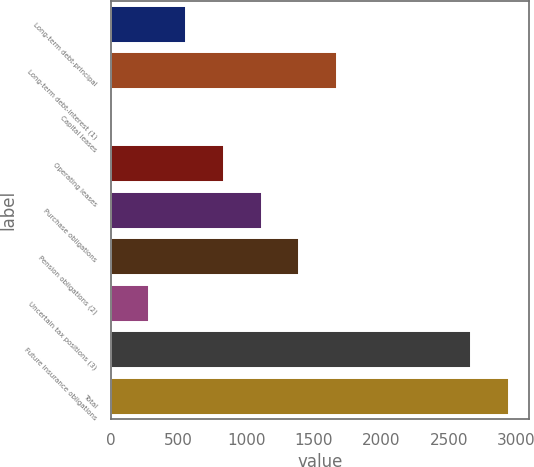Convert chart to OTSL. <chart><loc_0><loc_0><loc_500><loc_500><bar_chart><fcel>Long-term debt-principal<fcel>Long-term debt-interest (1)<fcel>Capital leases<fcel>Operating leases<fcel>Purchase obligations<fcel>Pension obligations (2)<fcel>Uncertain tax positions (3)<fcel>Future insurance obligations<fcel>Total<nl><fcel>557.08<fcel>1670.52<fcel>0.36<fcel>835.44<fcel>1113.8<fcel>1392.16<fcel>278.72<fcel>2666<fcel>2944.36<nl></chart> 